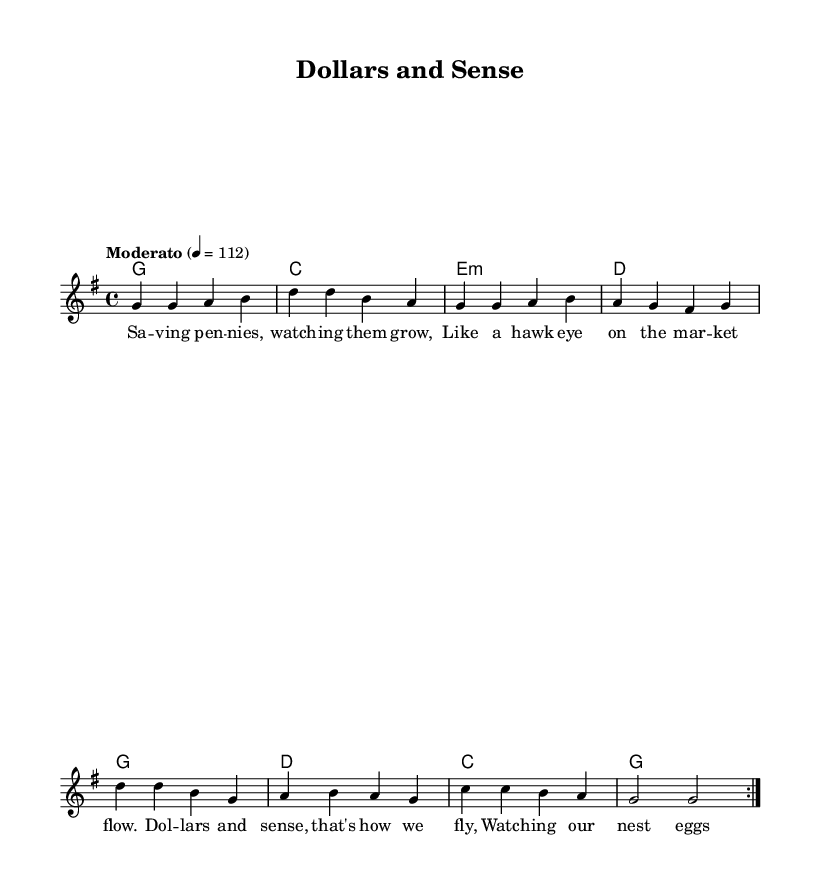What is the key signature of this music? The key signature is G major, which has one sharp (F#).
Answer: G major What is the time signature of this music? The time signature is 4/4, indicating four beats per measure.
Answer: 4/4 What is the tempo marking for this piece? The tempo marking is "Moderato," set at a quarter note equals 112 beats per minute.
Answer: Moderato How many times does the melody repeat in the verse? The melody repeats 2 times in the verse section as indicated by the repeat markings.
Answer: 2 What is the first lyric line of the song? The first lyric line is "Saving pennies, watching them grow," which sets the theme of financial growth.
Answer: Saving pennies, watching them grow What is the progression of the harmonies for the first volta? The harmonies for the first volta are G, C, E minor, and D. This reflects common chord progressions in country rock.
Answer: G, C, E minor, D What financial concept is illustrated by the lyrics? The lyrics illustrate the concept of saving and watching investments grow, emphasizing financial prudence and monitoring market trends.
Answer: Saving and watching investments grow 